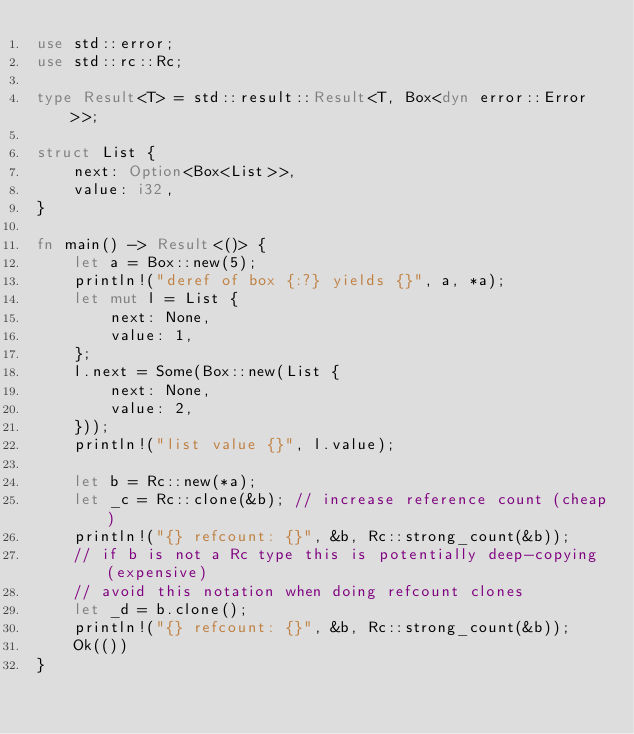Convert code to text. <code><loc_0><loc_0><loc_500><loc_500><_Rust_>use std::error;
use std::rc::Rc;

type Result<T> = std::result::Result<T, Box<dyn error::Error>>;

struct List {
    next: Option<Box<List>>,
    value: i32,
}

fn main() -> Result<()> {
    let a = Box::new(5);
    println!("deref of box {:?} yields {}", a, *a);
    let mut l = List {
        next: None,
        value: 1,
    };
    l.next = Some(Box::new(List {
        next: None,
        value: 2,
    }));
    println!("list value {}", l.value);

    let b = Rc::new(*a);
    let _c = Rc::clone(&b); // increase reference count (cheap)
    println!("{} refcount: {}", &b, Rc::strong_count(&b));
    // if b is not a Rc type this is potentially deep-copying (expensive)
    // avoid this notation when doing refcount clones
    let _d = b.clone();
    println!("{} refcount: {}", &b, Rc::strong_count(&b));
    Ok(())
}
</code> 